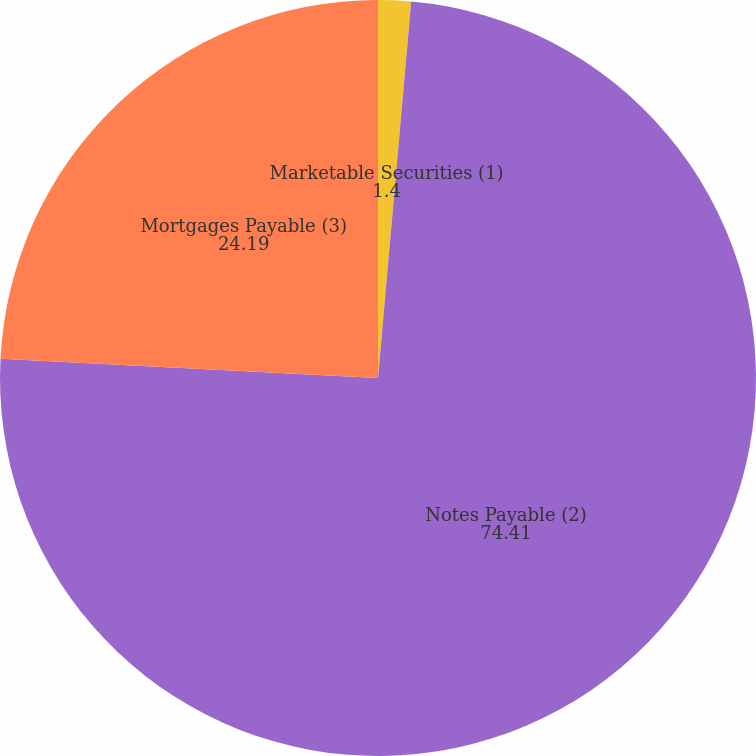<chart> <loc_0><loc_0><loc_500><loc_500><pie_chart><fcel>Marketable Securities (1)<fcel>Notes Payable (2)<fcel>Mortgages Payable (3)<nl><fcel>1.4%<fcel>74.41%<fcel>24.19%<nl></chart> 